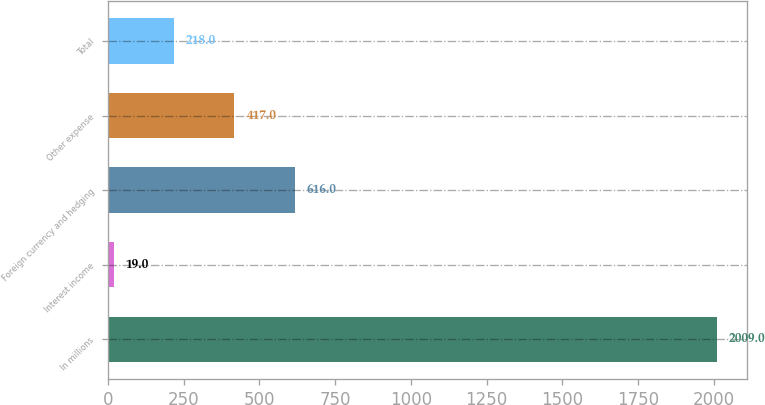<chart> <loc_0><loc_0><loc_500><loc_500><bar_chart><fcel>In millions<fcel>Interest income<fcel>Foreign currency and hedging<fcel>Other expense<fcel>Total<nl><fcel>2009<fcel>19<fcel>616<fcel>417<fcel>218<nl></chart> 